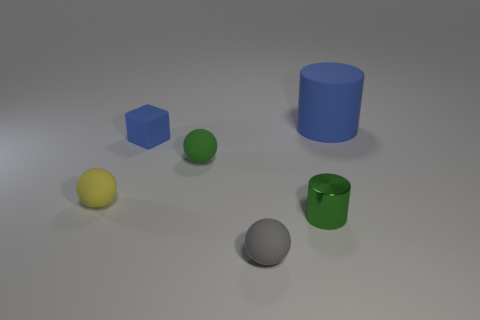What kind of lighting is used in this scene? The diffuse shadows and soft highlights indicate the use of a soft and indirect lighting source, resembling natural light or a photography studio setup with softbox lighting. 